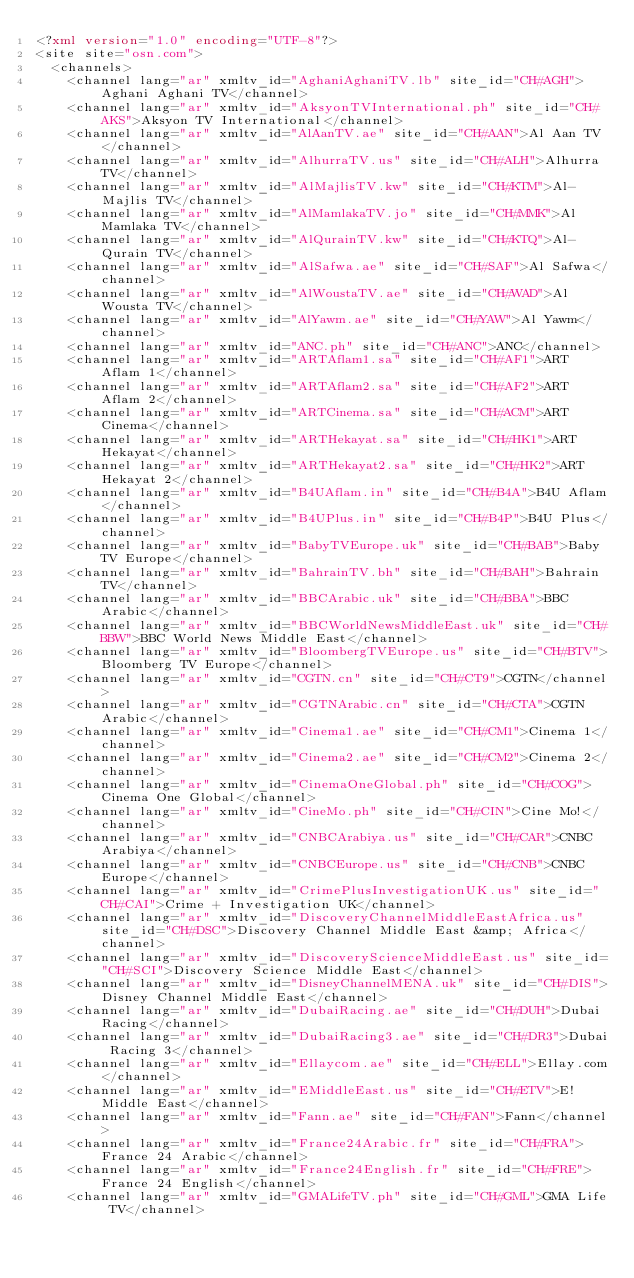Convert code to text. <code><loc_0><loc_0><loc_500><loc_500><_XML_><?xml version="1.0" encoding="UTF-8"?>
<site site="osn.com">
  <channels>
    <channel lang="ar" xmltv_id="AghaniAghaniTV.lb" site_id="CH#AGH">Aghani Aghani TV</channel>
    <channel lang="ar" xmltv_id="AksyonTVInternational.ph" site_id="CH#AKS">Aksyon TV International</channel>
    <channel lang="ar" xmltv_id="AlAanTV.ae" site_id="CH#AAN">Al Aan TV</channel>
    <channel lang="ar" xmltv_id="AlhurraTV.us" site_id="CH#ALH">Alhurra TV</channel>
    <channel lang="ar" xmltv_id="AlMajlisTV.kw" site_id="CH#KTM">Al-Majlis TV</channel>
    <channel lang="ar" xmltv_id="AlMamlakaTV.jo" site_id="CH#MMK">Al Mamlaka TV</channel>
    <channel lang="ar" xmltv_id="AlQurainTV.kw" site_id="CH#KTQ">Al-Qurain TV</channel>
    <channel lang="ar" xmltv_id="AlSafwa.ae" site_id="CH#SAF">Al Safwa</channel>
    <channel lang="ar" xmltv_id="AlWoustaTV.ae" site_id="CH#WAD">Al Wousta TV</channel>
    <channel lang="ar" xmltv_id="AlYawm.ae" site_id="CH#YAW">Al Yawm</channel>
    <channel lang="ar" xmltv_id="ANC.ph" site_id="CH#ANC">ANC</channel>
    <channel lang="ar" xmltv_id="ARTAflam1.sa" site_id="CH#AF1">ART Aflam 1</channel>
    <channel lang="ar" xmltv_id="ARTAflam2.sa" site_id="CH#AF2">ART Aflam 2</channel>
    <channel lang="ar" xmltv_id="ARTCinema.sa" site_id="CH#ACM">ART Cinema</channel>
    <channel lang="ar" xmltv_id="ARTHekayat.sa" site_id="CH#HK1">ART Hekayat</channel>
    <channel lang="ar" xmltv_id="ARTHekayat2.sa" site_id="CH#HK2">ART Hekayat 2</channel>
    <channel lang="ar" xmltv_id="B4UAflam.in" site_id="CH#B4A">B4U Aflam</channel>
    <channel lang="ar" xmltv_id="B4UPlus.in" site_id="CH#B4P">B4U Plus</channel>
    <channel lang="ar" xmltv_id="BabyTVEurope.uk" site_id="CH#BAB">Baby TV Europe</channel>
    <channel lang="ar" xmltv_id="BahrainTV.bh" site_id="CH#BAH">Bahrain TV</channel>
    <channel lang="ar" xmltv_id="BBCArabic.uk" site_id="CH#BBA">BBC Arabic</channel>
    <channel lang="ar" xmltv_id="BBCWorldNewsMiddleEast.uk" site_id="CH#BBW">BBC World News Middle East</channel>
    <channel lang="ar" xmltv_id="BloombergTVEurope.us" site_id="CH#BTV">Bloomberg TV Europe</channel>
    <channel lang="ar" xmltv_id="CGTN.cn" site_id="CH#CT9">CGTN</channel>
    <channel lang="ar" xmltv_id="CGTNArabic.cn" site_id="CH#CTA">CGTN Arabic</channel>
    <channel lang="ar" xmltv_id="Cinema1.ae" site_id="CH#CM1">Cinema 1</channel>
    <channel lang="ar" xmltv_id="Cinema2.ae" site_id="CH#CM2">Cinema 2</channel>
    <channel lang="ar" xmltv_id="CinemaOneGlobal.ph" site_id="CH#COG">Cinema One Global</channel>
    <channel lang="ar" xmltv_id="CineMo.ph" site_id="CH#CIN">Cine Mo!</channel>
    <channel lang="ar" xmltv_id="CNBCArabiya.us" site_id="CH#CAR">CNBC Arabiya</channel>
    <channel lang="ar" xmltv_id="CNBCEurope.us" site_id="CH#CNB">CNBC Europe</channel>
    <channel lang="ar" xmltv_id="CrimePlusInvestigationUK.us" site_id="CH#CAI">Crime + Investigation UK</channel>
    <channel lang="ar" xmltv_id="DiscoveryChannelMiddleEastAfrica.us" site_id="CH#DSC">Discovery Channel Middle East &amp; Africa</channel>
    <channel lang="ar" xmltv_id="DiscoveryScienceMiddleEast.us" site_id="CH#SCI">Discovery Science Middle East</channel>
    <channel lang="ar" xmltv_id="DisneyChannelMENA.uk" site_id="CH#DIS">Disney Channel Middle East</channel>
    <channel lang="ar" xmltv_id="DubaiRacing.ae" site_id="CH#DUH">Dubai Racing</channel>
    <channel lang="ar" xmltv_id="DubaiRacing3.ae" site_id="CH#DR3">Dubai Racing 3</channel>
    <channel lang="ar" xmltv_id="Ellaycom.ae" site_id="CH#ELL">Ellay.com</channel>
    <channel lang="ar" xmltv_id="EMiddleEast.us" site_id="CH#ETV">E! Middle East</channel>
    <channel lang="ar" xmltv_id="Fann.ae" site_id="CH#FAN">Fann</channel>
    <channel lang="ar" xmltv_id="France24Arabic.fr" site_id="CH#FRA">France 24 Arabic</channel>
    <channel lang="ar" xmltv_id="France24English.fr" site_id="CH#FRE">France 24 English</channel>
    <channel lang="ar" xmltv_id="GMALifeTV.ph" site_id="CH#GML">GMA Life TV</channel></code> 